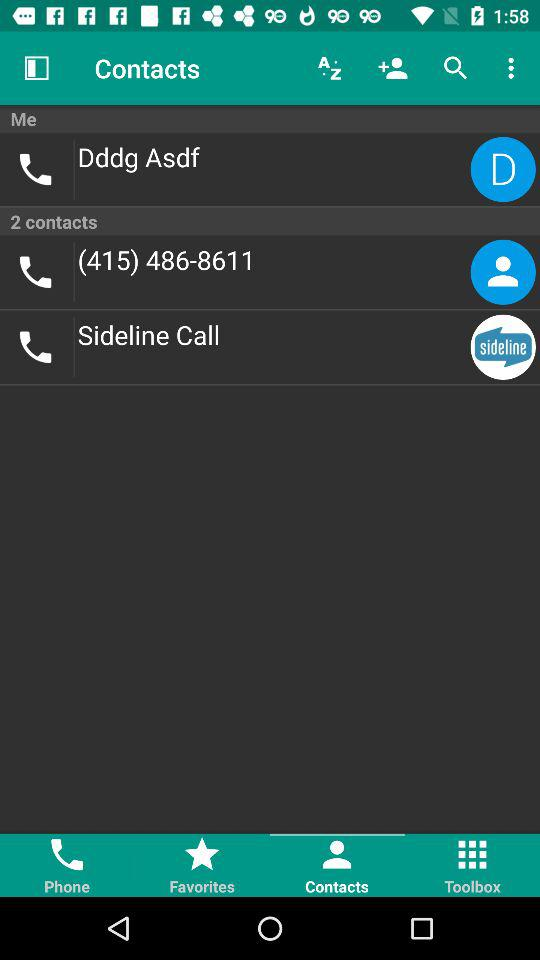Which tab is selected? The selected tab is "Contacts". 